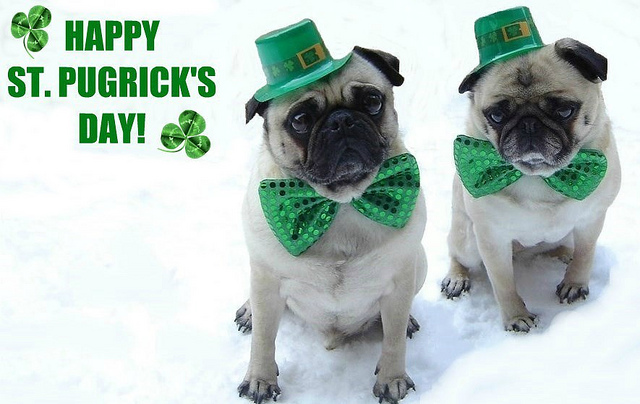Imagine if these pugs were exploring a magical forest. What would they find? As Paddy and Clovers ventured into the heart of the magical forest, they stumbled upon a hidden glade filled with dazzling shamrocks that glowed with a soft, otherworldly light. At the center of the glade stood an ancient tree with a door carved into its trunk, adorned with intricate Celtic designs. Curious, Paddy pushed the door open to reveal a cozy chamber where leprechauns welcomed them with a festive feast and stories of enchanted treasures. The pugs, with twinkling eyes, listened intently, savoring every magical moment. What would happen if these pugs were the mascots of a big St. Patrick's Day parade in Ireland? In Ireland for St. Patrick's Day, Paddy and Clovers were the stars of the grand parade. Dressed in their iconic green outfits, they led the parade float, crafted to resemble a giant four-leaf clover, through the cobblestone streets of Dublin. The streets were lined with thousands of cheering fans, waving flags and clapping to the rhythm of traditional Irish music. The pugs, with pride in their hearts, wagged their tails vigorously as they waved paws at the children and posed for countless photos, adding an unforgettable charm to the celebrations. 